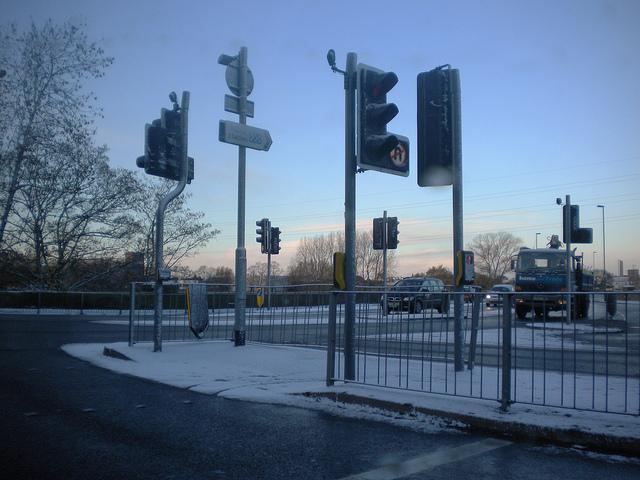How many vehicles are in view?
Give a very brief answer. 3. How many traffic lights are there?
Give a very brief answer. 3. 